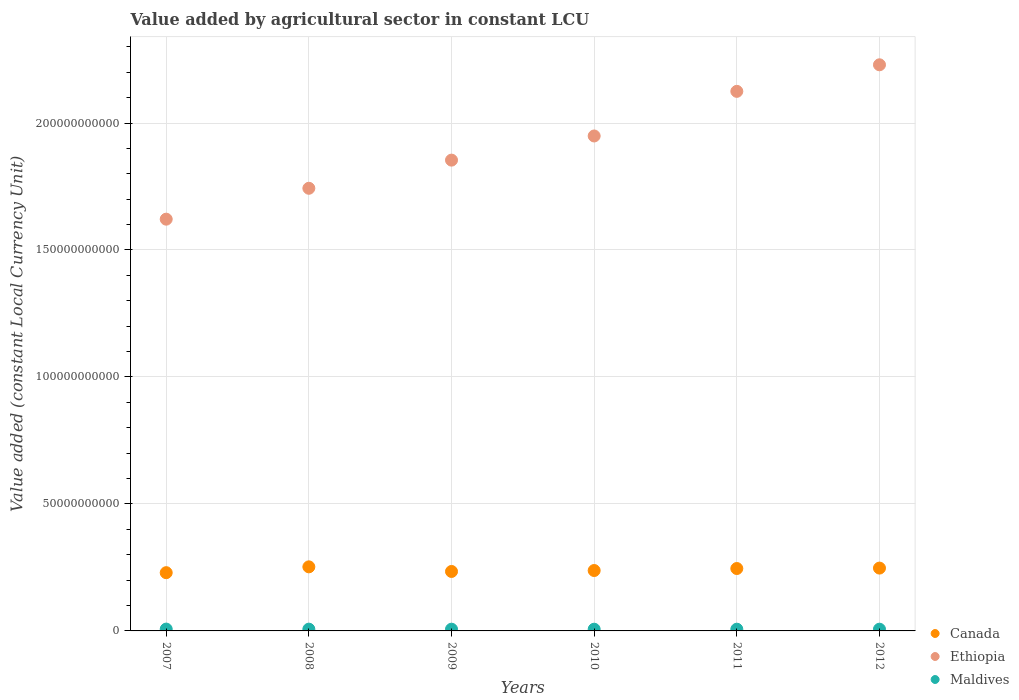How many different coloured dotlines are there?
Keep it short and to the point. 3. What is the value added by agricultural sector in Canada in 2009?
Your answer should be compact. 2.34e+1. Across all years, what is the maximum value added by agricultural sector in Maldives?
Make the answer very short. 7.23e+08. Across all years, what is the minimum value added by agricultural sector in Maldives?
Provide a succinct answer. 6.75e+08. What is the total value added by agricultural sector in Canada in the graph?
Provide a succinct answer. 1.45e+11. What is the difference between the value added by agricultural sector in Maldives in 2009 and that in 2010?
Provide a succinct answer. 5.98e+06. What is the difference between the value added by agricultural sector in Canada in 2012 and the value added by agricultural sector in Ethiopia in 2007?
Offer a terse response. -1.37e+11. What is the average value added by agricultural sector in Ethiopia per year?
Offer a terse response. 1.92e+11. In the year 2008, what is the difference between the value added by agricultural sector in Ethiopia and value added by agricultural sector in Maldives?
Provide a short and direct response. 1.74e+11. In how many years, is the value added by agricultural sector in Ethiopia greater than 140000000000 LCU?
Offer a very short reply. 6. What is the ratio of the value added by agricultural sector in Maldives in 2008 to that in 2012?
Your response must be concise. 1.02. Is the value added by agricultural sector in Canada in 2008 less than that in 2010?
Make the answer very short. No. What is the difference between the highest and the second highest value added by agricultural sector in Ethiopia?
Keep it short and to the point. 1.05e+1. What is the difference between the highest and the lowest value added by agricultural sector in Ethiopia?
Make the answer very short. 6.08e+1. In how many years, is the value added by agricultural sector in Canada greater than the average value added by agricultural sector in Canada taken over all years?
Provide a succinct answer. 3. Is the sum of the value added by agricultural sector in Maldives in 2009 and 2011 greater than the maximum value added by agricultural sector in Canada across all years?
Provide a short and direct response. No. Is the value added by agricultural sector in Maldives strictly greater than the value added by agricultural sector in Ethiopia over the years?
Keep it short and to the point. No. Is the value added by agricultural sector in Canada strictly less than the value added by agricultural sector in Maldives over the years?
Your answer should be compact. No. How many years are there in the graph?
Your answer should be very brief. 6. What is the difference between two consecutive major ticks on the Y-axis?
Make the answer very short. 5.00e+1. Does the graph contain any zero values?
Your response must be concise. No. Does the graph contain grids?
Provide a short and direct response. Yes. Where does the legend appear in the graph?
Offer a very short reply. Bottom right. How many legend labels are there?
Make the answer very short. 3. What is the title of the graph?
Provide a short and direct response. Value added by agricultural sector in constant LCU. What is the label or title of the Y-axis?
Offer a very short reply. Value added (constant Local Currency Unit). What is the Value added (constant Local Currency Unit) of Canada in 2007?
Offer a very short reply. 2.29e+1. What is the Value added (constant Local Currency Unit) of Ethiopia in 2007?
Keep it short and to the point. 1.62e+11. What is the Value added (constant Local Currency Unit) of Maldives in 2007?
Your answer should be compact. 7.23e+08. What is the Value added (constant Local Currency Unit) in Canada in 2008?
Keep it short and to the point. 2.52e+1. What is the Value added (constant Local Currency Unit) of Ethiopia in 2008?
Give a very brief answer. 1.74e+11. What is the Value added (constant Local Currency Unit) of Maldives in 2008?
Ensure brevity in your answer.  6.98e+08. What is the Value added (constant Local Currency Unit) of Canada in 2009?
Provide a short and direct response. 2.34e+1. What is the Value added (constant Local Currency Unit) in Ethiopia in 2009?
Provide a succinct answer. 1.85e+11. What is the Value added (constant Local Currency Unit) in Maldives in 2009?
Provide a succinct answer. 6.81e+08. What is the Value added (constant Local Currency Unit) in Canada in 2010?
Your response must be concise. 2.38e+1. What is the Value added (constant Local Currency Unit) in Ethiopia in 2010?
Keep it short and to the point. 1.95e+11. What is the Value added (constant Local Currency Unit) in Maldives in 2010?
Give a very brief answer. 6.75e+08. What is the Value added (constant Local Currency Unit) of Canada in 2011?
Offer a very short reply. 2.46e+1. What is the Value added (constant Local Currency Unit) of Ethiopia in 2011?
Your answer should be very brief. 2.12e+11. What is the Value added (constant Local Currency Unit) of Maldives in 2011?
Ensure brevity in your answer.  6.82e+08. What is the Value added (constant Local Currency Unit) of Canada in 2012?
Provide a short and direct response. 2.47e+1. What is the Value added (constant Local Currency Unit) of Ethiopia in 2012?
Provide a short and direct response. 2.23e+11. What is the Value added (constant Local Currency Unit) in Maldives in 2012?
Provide a short and direct response. 6.82e+08. Across all years, what is the maximum Value added (constant Local Currency Unit) in Canada?
Your answer should be compact. 2.52e+1. Across all years, what is the maximum Value added (constant Local Currency Unit) of Ethiopia?
Provide a succinct answer. 2.23e+11. Across all years, what is the maximum Value added (constant Local Currency Unit) in Maldives?
Make the answer very short. 7.23e+08. Across all years, what is the minimum Value added (constant Local Currency Unit) in Canada?
Offer a very short reply. 2.29e+1. Across all years, what is the minimum Value added (constant Local Currency Unit) in Ethiopia?
Offer a very short reply. 1.62e+11. Across all years, what is the minimum Value added (constant Local Currency Unit) in Maldives?
Keep it short and to the point. 6.75e+08. What is the total Value added (constant Local Currency Unit) of Canada in the graph?
Your answer should be compact. 1.45e+11. What is the total Value added (constant Local Currency Unit) of Ethiopia in the graph?
Offer a terse response. 1.15e+12. What is the total Value added (constant Local Currency Unit) in Maldives in the graph?
Provide a short and direct response. 4.14e+09. What is the difference between the Value added (constant Local Currency Unit) of Canada in 2007 and that in 2008?
Provide a succinct answer. -2.30e+09. What is the difference between the Value added (constant Local Currency Unit) of Ethiopia in 2007 and that in 2008?
Your answer should be compact. -1.22e+1. What is the difference between the Value added (constant Local Currency Unit) in Maldives in 2007 and that in 2008?
Keep it short and to the point. 2.45e+07. What is the difference between the Value added (constant Local Currency Unit) in Canada in 2007 and that in 2009?
Your response must be concise. -4.77e+08. What is the difference between the Value added (constant Local Currency Unit) in Ethiopia in 2007 and that in 2009?
Your response must be concise. -2.33e+1. What is the difference between the Value added (constant Local Currency Unit) of Maldives in 2007 and that in 2009?
Your answer should be very brief. 4.17e+07. What is the difference between the Value added (constant Local Currency Unit) in Canada in 2007 and that in 2010?
Ensure brevity in your answer.  -8.49e+08. What is the difference between the Value added (constant Local Currency Unit) in Ethiopia in 2007 and that in 2010?
Keep it short and to the point. -3.28e+1. What is the difference between the Value added (constant Local Currency Unit) in Maldives in 2007 and that in 2010?
Provide a succinct answer. 4.77e+07. What is the difference between the Value added (constant Local Currency Unit) in Canada in 2007 and that in 2011?
Make the answer very short. -1.64e+09. What is the difference between the Value added (constant Local Currency Unit) of Ethiopia in 2007 and that in 2011?
Provide a short and direct response. -5.03e+1. What is the difference between the Value added (constant Local Currency Unit) in Maldives in 2007 and that in 2011?
Make the answer very short. 4.06e+07. What is the difference between the Value added (constant Local Currency Unit) in Canada in 2007 and that in 2012?
Provide a succinct answer. -1.80e+09. What is the difference between the Value added (constant Local Currency Unit) of Ethiopia in 2007 and that in 2012?
Your response must be concise. -6.08e+1. What is the difference between the Value added (constant Local Currency Unit) in Maldives in 2007 and that in 2012?
Keep it short and to the point. 4.09e+07. What is the difference between the Value added (constant Local Currency Unit) of Canada in 2008 and that in 2009?
Give a very brief answer. 1.82e+09. What is the difference between the Value added (constant Local Currency Unit) in Ethiopia in 2008 and that in 2009?
Provide a short and direct response. -1.11e+1. What is the difference between the Value added (constant Local Currency Unit) of Maldives in 2008 and that in 2009?
Your answer should be compact. 1.72e+07. What is the difference between the Value added (constant Local Currency Unit) in Canada in 2008 and that in 2010?
Ensure brevity in your answer.  1.45e+09. What is the difference between the Value added (constant Local Currency Unit) in Ethiopia in 2008 and that in 2010?
Make the answer very short. -2.06e+1. What is the difference between the Value added (constant Local Currency Unit) in Maldives in 2008 and that in 2010?
Make the answer very short. 2.32e+07. What is the difference between the Value added (constant Local Currency Unit) of Canada in 2008 and that in 2011?
Ensure brevity in your answer.  6.58e+08. What is the difference between the Value added (constant Local Currency Unit) of Ethiopia in 2008 and that in 2011?
Provide a short and direct response. -3.82e+1. What is the difference between the Value added (constant Local Currency Unit) of Maldives in 2008 and that in 2011?
Give a very brief answer. 1.60e+07. What is the difference between the Value added (constant Local Currency Unit) of Canada in 2008 and that in 2012?
Your answer should be compact. 4.92e+08. What is the difference between the Value added (constant Local Currency Unit) of Ethiopia in 2008 and that in 2012?
Your response must be concise. -4.86e+1. What is the difference between the Value added (constant Local Currency Unit) of Maldives in 2008 and that in 2012?
Ensure brevity in your answer.  1.63e+07. What is the difference between the Value added (constant Local Currency Unit) in Canada in 2009 and that in 2010?
Keep it short and to the point. -3.73e+08. What is the difference between the Value added (constant Local Currency Unit) in Ethiopia in 2009 and that in 2010?
Your response must be concise. -9.51e+09. What is the difference between the Value added (constant Local Currency Unit) in Maldives in 2009 and that in 2010?
Ensure brevity in your answer.  5.98e+06. What is the difference between the Value added (constant Local Currency Unit) in Canada in 2009 and that in 2011?
Provide a short and direct response. -1.16e+09. What is the difference between the Value added (constant Local Currency Unit) of Ethiopia in 2009 and that in 2011?
Provide a succinct answer. -2.71e+1. What is the difference between the Value added (constant Local Currency Unit) in Maldives in 2009 and that in 2011?
Provide a short and direct response. -1.15e+06. What is the difference between the Value added (constant Local Currency Unit) in Canada in 2009 and that in 2012?
Your answer should be very brief. -1.33e+09. What is the difference between the Value added (constant Local Currency Unit) of Ethiopia in 2009 and that in 2012?
Ensure brevity in your answer.  -3.75e+1. What is the difference between the Value added (constant Local Currency Unit) of Maldives in 2009 and that in 2012?
Ensure brevity in your answer.  -8.87e+05. What is the difference between the Value added (constant Local Currency Unit) in Canada in 2010 and that in 2011?
Your answer should be very brief. -7.89e+08. What is the difference between the Value added (constant Local Currency Unit) of Ethiopia in 2010 and that in 2011?
Offer a very short reply. -1.76e+1. What is the difference between the Value added (constant Local Currency Unit) of Maldives in 2010 and that in 2011?
Your answer should be compact. -7.13e+06. What is the difference between the Value added (constant Local Currency Unit) of Canada in 2010 and that in 2012?
Keep it short and to the point. -9.55e+08. What is the difference between the Value added (constant Local Currency Unit) in Ethiopia in 2010 and that in 2012?
Give a very brief answer. -2.80e+1. What is the difference between the Value added (constant Local Currency Unit) in Maldives in 2010 and that in 2012?
Provide a short and direct response. -6.86e+06. What is the difference between the Value added (constant Local Currency Unit) of Canada in 2011 and that in 2012?
Your answer should be compact. -1.67e+08. What is the difference between the Value added (constant Local Currency Unit) in Ethiopia in 2011 and that in 2012?
Offer a terse response. -1.05e+1. What is the difference between the Value added (constant Local Currency Unit) in Maldives in 2011 and that in 2012?
Ensure brevity in your answer.  2.63e+05. What is the difference between the Value added (constant Local Currency Unit) of Canada in 2007 and the Value added (constant Local Currency Unit) of Ethiopia in 2008?
Offer a very short reply. -1.51e+11. What is the difference between the Value added (constant Local Currency Unit) of Canada in 2007 and the Value added (constant Local Currency Unit) of Maldives in 2008?
Make the answer very short. 2.22e+1. What is the difference between the Value added (constant Local Currency Unit) in Ethiopia in 2007 and the Value added (constant Local Currency Unit) in Maldives in 2008?
Ensure brevity in your answer.  1.61e+11. What is the difference between the Value added (constant Local Currency Unit) in Canada in 2007 and the Value added (constant Local Currency Unit) in Ethiopia in 2009?
Offer a very short reply. -1.62e+11. What is the difference between the Value added (constant Local Currency Unit) in Canada in 2007 and the Value added (constant Local Currency Unit) in Maldives in 2009?
Give a very brief answer. 2.23e+1. What is the difference between the Value added (constant Local Currency Unit) in Ethiopia in 2007 and the Value added (constant Local Currency Unit) in Maldives in 2009?
Keep it short and to the point. 1.61e+11. What is the difference between the Value added (constant Local Currency Unit) of Canada in 2007 and the Value added (constant Local Currency Unit) of Ethiopia in 2010?
Your answer should be very brief. -1.72e+11. What is the difference between the Value added (constant Local Currency Unit) in Canada in 2007 and the Value added (constant Local Currency Unit) in Maldives in 2010?
Offer a terse response. 2.23e+1. What is the difference between the Value added (constant Local Currency Unit) in Ethiopia in 2007 and the Value added (constant Local Currency Unit) in Maldives in 2010?
Keep it short and to the point. 1.61e+11. What is the difference between the Value added (constant Local Currency Unit) in Canada in 2007 and the Value added (constant Local Currency Unit) in Ethiopia in 2011?
Your response must be concise. -1.90e+11. What is the difference between the Value added (constant Local Currency Unit) of Canada in 2007 and the Value added (constant Local Currency Unit) of Maldives in 2011?
Ensure brevity in your answer.  2.23e+1. What is the difference between the Value added (constant Local Currency Unit) of Ethiopia in 2007 and the Value added (constant Local Currency Unit) of Maldives in 2011?
Provide a short and direct response. 1.61e+11. What is the difference between the Value added (constant Local Currency Unit) of Canada in 2007 and the Value added (constant Local Currency Unit) of Ethiopia in 2012?
Offer a terse response. -2.00e+11. What is the difference between the Value added (constant Local Currency Unit) of Canada in 2007 and the Value added (constant Local Currency Unit) of Maldives in 2012?
Make the answer very short. 2.23e+1. What is the difference between the Value added (constant Local Currency Unit) in Ethiopia in 2007 and the Value added (constant Local Currency Unit) in Maldives in 2012?
Ensure brevity in your answer.  1.61e+11. What is the difference between the Value added (constant Local Currency Unit) in Canada in 2008 and the Value added (constant Local Currency Unit) in Ethiopia in 2009?
Your response must be concise. -1.60e+11. What is the difference between the Value added (constant Local Currency Unit) in Canada in 2008 and the Value added (constant Local Currency Unit) in Maldives in 2009?
Provide a short and direct response. 2.46e+1. What is the difference between the Value added (constant Local Currency Unit) in Ethiopia in 2008 and the Value added (constant Local Currency Unit) in Maldives in 2009?
Keep it short and to the point. 1.74e+11. What is the difference between the Value added (constant Local Currency Unit) in Canada in 2008 and the Value added (constant Local Currency Unit) in Ethiopia in 2010?
Keep it short and to the point. -1.70e+11. What is the difference between the Value added (constant Local Currency Unit) of Canada in 2008 and the Value added (constant Local Currency Unit) of Maldives in 2010?
Provide a succinct answer. 2.46e+1. What is the difference between the Value added (constant Local Currency Unit) of Ethiopia in 2008 and the Value added (constant Local Currency Unit) of Maldives in 2010?
Your answer should be compact. 1.74e+11. What is the difference between the Value added (constant Local Currency Unit) in Canada in 2008 and the Value added (constant Local Currency Unit) in Ethiopia in 2011?
Keep it short and to the point. -1.87e+11. What is the difference between the Value added (constant Local Currency Unit) in Canada in 2008 and the Value added (constant Local Currency Unit) in Maldives in 2011?
Ensure brevity in your answer.  2.45e+1. What is the difference between the Value added (constant Local Currency Unit) in Ethiopia in 2008 and the Value added (constant Local Currency Unit) in Maldives in 2011?
Ensure brevity in your answer.  1.74e+11. What is the difference between the Value added (constant Local Currency Unit) of Canada in 2008 and the Value added (constant Local Currency Unit) of Ethiopia in 2012?
Make the answer very short. -1.98e+11. What is the difference between the Value added (constant Local Currency Unit) in Canada in 2008 and the Value added (constant Local Currency Unit) in Maldives in 2012?
Your response must be concise. 2.46e+1. What is the difference between the Value added (constant Local Currency Unit) in Ethiopia in 2008 and the Value added (constant Local Currency Unit) in Maldives in 2012?
Offer a very short reply. 1.74e+11. What is the difference between the Value added (constant Local Currency Unit) in Canada in 2009 and the Value added (constant Local Currency Unit) in Ethiopia in 2010?
Offer a very short reply. -1.71e+11. What is the difference between the Value added (constant Local Currency Unit) of Canada in 2009 and the Value added (constant Local Currency Unit) of Maldives in 2010?
Your answer should be compact. 2.27e+1. What is the difference between the Value added (constant Local Currency Unit) in Ethiopia in 2009 and the Value added (constant Local Currency Unit) in Maldives in 2010?
Make the answer very short. 1.85e+11. What is the difference between the Value added (constant Local Currency Unit) in Canada in 2009 and the Value added (constant Local Currency Unit) in Ethiopia in 2011?
Provide a short and direct response. -1.89e+11. What is the difference between the Value added (constant Local Currency Unit) in Canada in 2009 and the Value added (constant Local Currency Unit) in Maldives in 2011?
Give a very brief answer. 2.27e+1. What is the difference between the Value added (constant Local Currency Unit) of Ethiopia in 2009 and the Value added (constant Local Currency Unit) of Maldives in 2011?
Ensure brevity in your answer.  1.85e+11. What is the difference between the Value added (constant Local Currency Unit) of Canada in 2009 and the Value added (constant Local Currency Unit) of Ethiopia in 2012?
Keep it short and to the point. -2.00e+11. What is the difference between the Value added (constant Local Currency Unit) in Canada in 2009 and the Value added (constant Local Currency Unit) in Maldives in 2012?
Provide a short and direct response. 2.27e+1. What is the difference between the Value added (constant Local Currency Unit) in Ethiopia in 2009 and the Value added (constant Local Currency Unit) in Maldives in 2012?
Ensure brevity in your answer.  1.85e+11. What is the difference between the Value added (constant Local Currency Unit) in Canada in 2010 and the Value added (constant Local Currency Unit) in Ethiopia in 2011?
Provide a short and direct response. -1.89e+11. What is the difference between the Value added (constant Local Currency Unit) of Canada in 2010 and the Value added (constant Local Currency Unit) of Maldives in 2011?
Keep it short and to the point. 2.31e+1. What is the difference between the Value added (constant Local Currency Unit) of Ethiopia in 2010 and the Value added (constant Local Currency Unit) of Maldives in 2011?
Offer a very short reply. 1.94e+11. What is the difference between the Value added (constant Local Currency Unit) of Canada in 2010 and the Value added (constant Local Currency Unit) of Ethiopia in 2012?
Offer a very short reply. -1.99e+11. What is the difference between the Value added (constant Local Currency Unit) in Canada in 2010 and the Value added (constant Local Currency Unit) in Maldives in 2012?
Ensure brevity in your answer.  2.31e+1. What is the difference between the Value added (constant Local Currency Unit) of Ethiopia in 2010 and the Value added (constant Local Currency Unit) of Maldives in 2012?
Your response must be concise. 1.94e+11. What is the difference between the Value added (constant Local Currency Unit) of Canada in 2011 and the Value added (constant Local Currency Unit) of Ethiopia in 2012?
Offer a very short reply. -1.98e+11. What is the difference between the Value added (constant Local Currency Unit) of Canada in 2011 and the Value added (constant Local Currency Unit) of Maldives in 2012?
Your answer should be compact. 2.39e+1. What is the difference between the Value added (constant Local Currency Unit) of Ethiopia in 2011 and the Value added (constant Local Currency Unit) of Maldives in 2012?
Your answer should be compact. 2.12e+11. What is the average Value added (constant Local Currency Unit) in Canada per year?
Make the answer very short. 2.41e+1. What is the average Value added (constant Local Currency Unit) in Ethiopia per year?
Your answer should be compact. 1.92e+11. What is the average Value added (constant Local Currency Unit) of Maldives per year?
Keep it short and to the point. 6.90e+08. In the year 2007, what is the difference between the Value added (constant Local Currency Unit) in Canada and Value added (constant Local Currency Unit) in Ethiopia?
Your response must be concise. -1.39e+11. In the year 2007, what is the difference between the Value added (constant Local Currency Unit) in Canada and Value added (constant Local Currency Unit) in Maldives?
Keep it short and to the point. 2.22e+1. In the year 2007, what is the difference between the Value added (constant Local Currency Unit) of Ethiopia and Value added (constant Local Currency Unit) of Maldives?
Offer a very short reply. 1.61e+11. In the year 2008, what is the difference between the Value added (constant Local Currency Unit) of Canada and Value added (constant Local Currency Unit) of Ethiopia?
Provide a succinct answer. -1.49e+11. In the year 2008, what is the difference between the Value added (constant Local Currency Unit) of Canada and Value added (constant Local Currency Unit) of Maldives?
Offer a very short reply. 2.45e+1. In the year 2008, what is the difference between the Value added (constant Local Currency Unit) in Ethiopia and Value added (constant Local Currency Unit) in Maldives?
Offer a very short reply. 1.74e+11. In the year 2009, what is the difference between the Value added (constant Local Currency Unit) in Canada and Value added (constant Local Currency Unit) in Ethiopia?
Make the answer very short. -1.62e+11. In the year 2009, what is the difference between the Value added (constant Local Currency Unit) in Canada and Value added (constant Local Currency Unit) in Maldives?
Offer a terse response. 2.27e+1. In the year 2009, what is the difference between the Value added (constant Local Currency Unit) in Ethiopia and Value added (constant Local Currency Unit) in Maldives?
Provide a succinct answer. 1.85e+11. In the year 2010, what is the difference between the Value added (constant Local Currency Unit) in Canada and Value added (constant Local Currency Unit) in Ethiopia?
Provide a short and direct response. -1.71e+11. In the year 2010, what is the difference between the Value added (constant Local Currency Unit) in Canada and Value added (constant Local Currency Unit) in Maldives?
Make the answer very short. 2.31e+1. In the year 2010, what is the difference between the Value added (constant Local Currency Unit) in Ethiopia and Value added (constant Local Currency Unit) in Maldives?
Your answer should be compact. 1.94e+11. In the year 2011, what is the difference between the Value added (constant Local Currency Unit) of Canada and Value added (constant Local Currency Unit) of Ethiopia?
Give a very brief answer. -1.88e+11. In the year 2011, what is the difference between the Value added (constant Local Currency Unit) of Canada and Value added (constant Local Currency Unit) of Maldives?
Your answer should be very brief. 2.39e+1. In the year 2011, what is the difference between the Value added (constant Local Currency Unit) of Ethiopia and Value added (constant Local Currency Unit) of Maldives?
Offer a terse response. 2.12e+11. In the year 2012, what is the difference between the Value added (constant Local Currency Unit) of Canada and Value added (constant Local Currency Unit) of Ethiopia?
Your answer should be compact. -1.98e+11. In the year 2012, what is the difference between the Value added (constant Local Currency Unit) in Canada and Value added (constant Local Currency Unit) in Maldives?
Keep it short and to the point. 2.41e+1. In the year 2012, what is the difference between the Value added (constant Local Currency Unit) of Ethiopia and Value added (constant Local Currency Unit) of Maldives?
Make the answer very short. 2.22e+11. What is the ratio of the Value added (constant Local Currency Unit) in Canada in 2007 to that in 2008?
Provide a short and direct response. 0.91. What is the ratio of the Value added (constant Local Currency Unit) in Ethiopia in 2007 to that in 2008?
Make the answer very short. 0.93. What is the ratio of the Value added (constant Local Currency Unit) in Maldives in 2007 to that in 2008?
Ensure brevity in your answer.  1.04. What is the ratio of the Value added (constant Local Currency Unit) of Canada in 2007 to that in 2009?
Your answer should be very brief. 0.98. What is the ratio of the Value added (constant Local Currency Unit) in Ethiopia in 2007 to that in 2009?
Offer a terse response. 0.87. What is the ratio of the Value added (constant Local Currency Unit) of Maldives in 2007 to that in 2009?
Your response must be concise. 1.06. What is the ratio of the Value added (constant Local Currency Unit) of Canada in 2007 to that in 2010?
Your answer should be compact. 0.96. What is the ratio of the Value added (constant Local Currency Unit) of Ethiopia in 2007 to that in 2010?
Your answer should be very brief. 0.83. What is the ratio of the Value added (constant Local Currency Unit) of Maldives in 2007 to that in 2010?
Your response must be concise. 1.07. What is the ratio of the Value added (constant Local Currency Unit) in Canada in 2007 to that in 2011?
Provide a succinct answer. 0.93. What is the ratio of the Value added (constant Local Currency Unit) of Ethiopia in 2007 to that in 2011?
Offer a very short reply. 0.76. What is the ratio of the Value added (constant Local Currency Unit) in Maldives in 2007 to that in 2011?
Keep it short and to the point. 1.06. What is the ratio of the Value added (constant Local Currency Unit) in Canada in 2007 to that in 2012?
Your response must be concise. 0.93. What is the ratio of the Value added (constant Local Currency Unit) in Ethiopia in 2007 to that in 2012?
Give a very brief answer. 0.73. What is the ratio of the Value added (constant Local Currency Unit) of Maldives in 2007 to that in 2012?
Give a very brief answer. 1.06. What is the ratio of the Value added (constant Local Currency Unit) in Canada in 2008 to that in 2009?
Your response must be concise. 1.08. What is the ratio of the Value added (constant Local Currency Unit) of Ethiopia in 2008 to that in 2009?
Provide a short and direct response. 0.94. What is the ratio of the Value added (constant Local Currency Unit) in Maldives in 2008 to that in 2009?
Your answer should be very brief. 1.03. What is the ratio of the Value added (constant Local Currency Unit) of Canada in 2008 to that in 2010?
Ensure brevity in your answer.  1.06. What is the ratio of the Value added (constant Local Currency Unit) in Ethiopia in 2008 to that in 2010?
Provide a short and direct response. 0.89. What is the ratio of the Value added (constant Local Currency Unit) in Maldives in 2008 to that in 2010?
Your response must be concise. 1.03. What is the ratio of the Value added (constant Local Currency Unit) of Canada in 2008 to that in 2011?
Give a very brief answer. 1.03. What is the ratio of the Value added (constant Local Currency Unit) in Ethiopia in 2008 to that in 2011?
Provide a succinct answer. 0.82. What is the ratio of the Value added (constant Local Currency Unit) in Maldives in 2008 to that in 2011?
Offer a very short reply. 1.02. What is the ratio of the Value added (constant Local Currency Unit) in Canada in 2008 to that in 2012?
Your response must be concise. 1.02. What is the ratio of the Value added (constant Local Currency Unit) of Ethiopia in 2008 to that in 2012?
Keep it short and to the point. 0.78. What is the ratio of the Value added (constant Local Currency Unit) of Maldives in 2008 to that in 2012?
Provide a succinct answer. 1.02. What is the ratio of the Value added (constant Local Currency Unit) of Canada in 2009 to that in 2010?
Ensure brevity in your answer.  0.98. What is the ratio of the Value added (constant Local Currency Unit) in Ethiopia in 2009 to that in 2010?
Offer a terse response. 0.95. What is the ratio of the Value added (constant Local Currency Unit) in Maldives in 2009 to that in 2010?
Provide a succinct answer. 1.01. What is the ratio of the Value added (constant Local Currency Unit) of Canada in 2009 to that in 2011?
Offer a very short reply. 0.95. What is the ratio of the Value added (constant Local Currency Unit) in Ethiopia in 2009 to that in 2011?
Keep it short and to the point. 0.87. What is the ratio of the Value added (constant Local Currency Unit) in Canada in 2009 to that in 2012?
Make the answer very short. 0.95. What is the ratio of the Value added (constant Local Currency Unit) in Ethiopia in 2009 to that in 2012?
Provide a short and direct response. 0.83. What is the ratio of the Value added (constant Local Currency Unit) in Canada in 2010 to that in 2011?
Keep it short and to the point. 0.97. What is the ratio of the Value added (constant Local Currency Unit) in Ethiopia in 2010 to that in 2011?
Ensure brevity in your answer.  0.92. What is the ratio of the Value added (constant Local Currency Unit) in Maldives in 2010 to that in 2011?
Give a very brief answer. 0.99. What is the ratio of the Value added (constant Local Currency Unit) in Canada in 2010 to that in 2012?
Provide a succinct answer. 0.96. What is the ratio of the Value added (constant Local Currency Unit) of Ethiopia in 2010 to that in 2012?
Your response must be concise. 0.87. What is the ratio of the Value added (constant Local Currency Unit) in Maldives in 2010 to that in 2012?
Give a very brief answer. 0.99. What is the ratio of the Value added (constant Local Currency Unit) in Canada in 2011 to that in 2012?
Your response must be concise. 0.99. What is the ratio of the Value added (constant Local Currency Unit) of Ethiopia in 2011 to that in 2012?
Your answer should be very brief. 0.95. What is the ratio of the Value added (constant Local Currency Unit) in Maldives in 2011 to that in 2012?
Offer a very short reply. 1. What is the difference between the highest and the second highest Value added (constant Local Currency Unit) of Canada?
Your answer should be compact. 4.92e+08. What is the difference between the highest and the second highest Value added (constant Local Currency Unit) in Ethiopia?
Make the answer very short. 1.05e+1. What is the difference between the highest and the second highest Value added (constant Local Currency Unit) of Maldives?
Your response must be concise. 2.45e+07. What is the difference between the highest and the lowest Value added (constant Local Currency Unit) in Canada?
Your answer should be compact. 2.30e+09. What is the difference between the highest and the lowest Value added (constant Local Currency Unit) in Ethiopia?
Ensure brevity in your answer.  6.08e+1. What is the difference between the highest and the lowest Value added (constant Local Currency Unit) of Maldives?
Provide a succinct answer. 4.77e+07. 